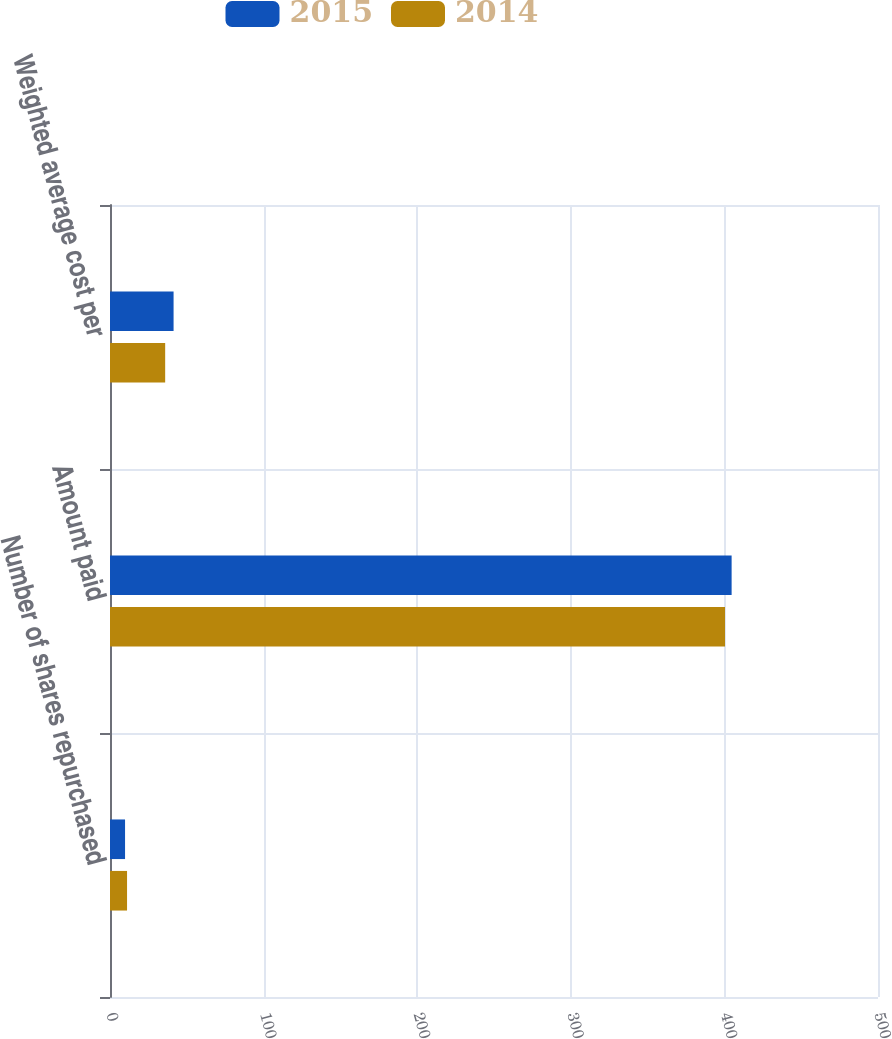Convert chart to OTSL. <chart><loc_0><loc_0><loc_500><loc_500><stacked_bar_chart><ecel><fcel>Number of shares repurchased<fcel>Amount paid<fcel>Weighted average cost per<nl><fcel>2015<fcel>9.8<fcel>404.7<fcel>41.39<nl><fcel>2014<fcel>11.1<fcel>400.4<fcel>35.92<nl></chart> 